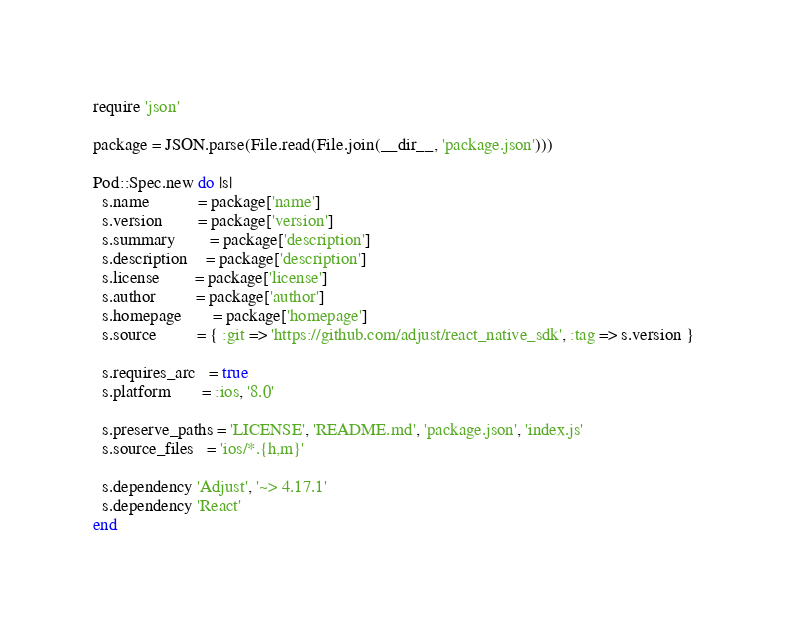<code> <loc_0><loc_0><loc_500><loc_500><_Ruby_>require 'json'

package = JSON.parse(File.read(File.join(__dir__, 'package.json')))

Pod::Spec.new do |s|
  s.name           = package['name']
  s.version        = package['version']
  s.summary        = package['description']
  s.description    = package['description']
  s.license        = package['license']
  s.author         = package['author']
  s.homepage       = package['homepage']
  s.source         = { :git => 'https://github.com/adjust/react_native_sdk', :tag => s.version }

  s.requires_arc   = true
  s.platform       = :ios, '8.0'

  s.preserve_paths = 'LICENSE', 'README.md', 'package.json', 'index.js'
  s.source_files   = 'ios/*.{h,m}'

  s.dependency 'Adjust', '~> 4.17.1'
  s.dependency 'React'
end
</code> 